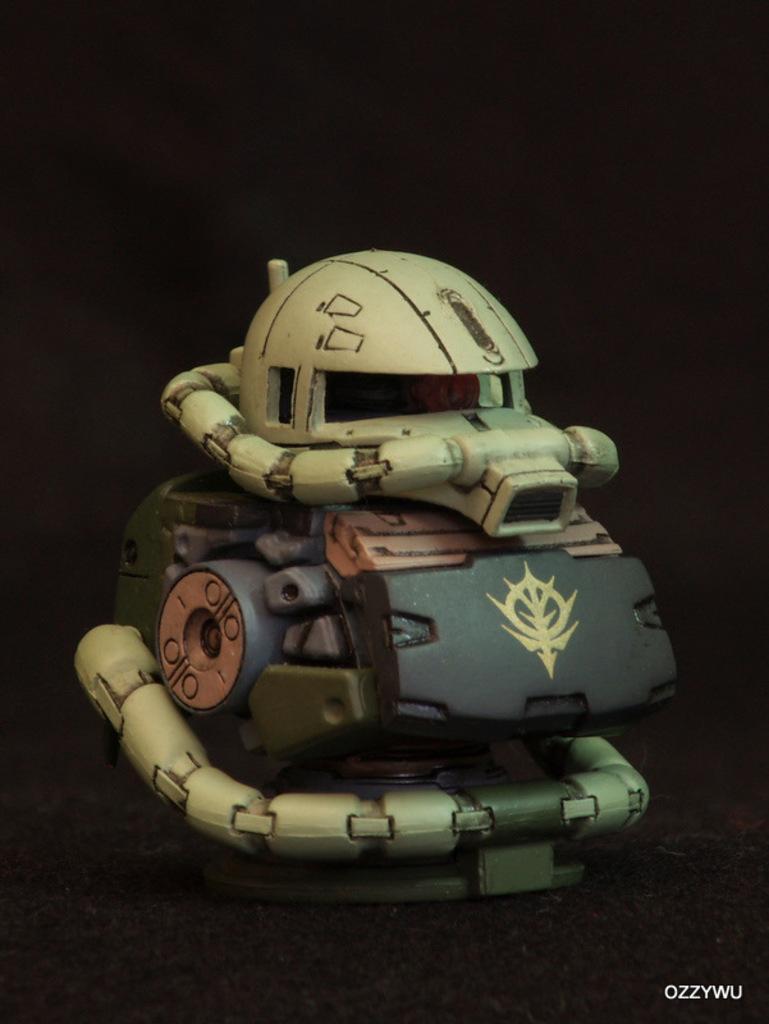Please provide a concise description of this image. In this picture I can see there is a toy placed on the surface and there is something written at the right bottom of the image and the backdrop is dark. 